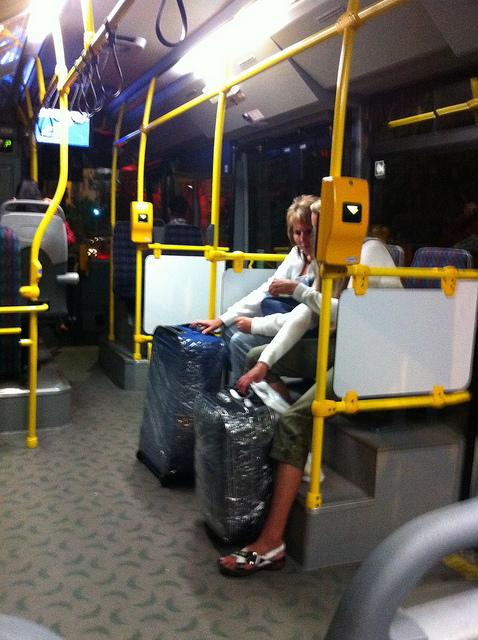Are both women holding suitcases?
Answer briefly. Yes. IS this woman wearing sneakers?
Keep it brief. No. Is this on a bus or train?
Quick response, please. Bus. 